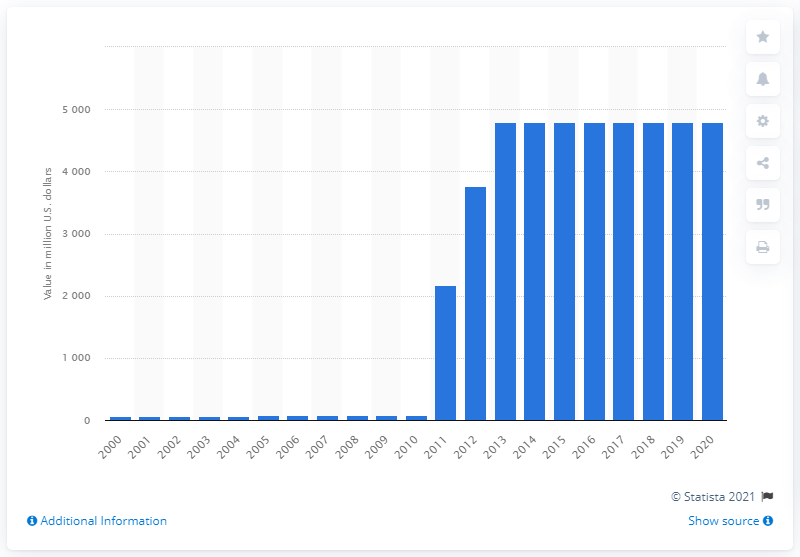Mention a couple of crucial points in this snapshot. The amount of gold reserves held by the Bank of Korea in 2020 was 47,947.60 metric tons. As of 2013, the Bank of Korea held a total of 4794.76 metric tons of gold reserves, accumulated over the period of 2011 and 2013. 